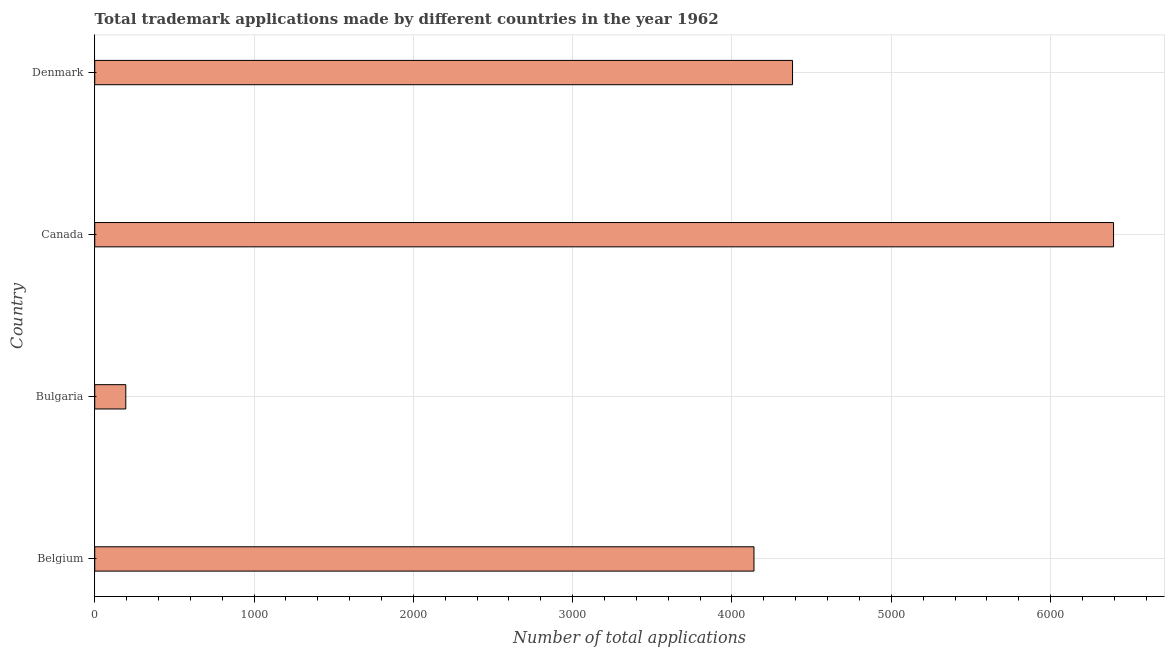What is the title of the graph?
Your response must be concise. Total trademark applications made by different countries in the year 1962. What is the label or title of the X-axis?
Your answer should be very brief. Number of total applications. What is the label or title of the Y-axis?
Offer a terse response. Country. What is the number of trademark applications in Denmark?
Give a very brief answer. 4380. Across all countries, what is the maximum number of trademark applications?
Provide a short and direct response. 6395. Across all countries, what is the minimum number of trademark applications?
Ensure brevity in your answer.  195. In which country was the number of trademark applications minimum?
Offer a terse response. Bulgaria. What is the sum of the number of trademark applications?
Offer a terse response. 1.51e+04. What is the difference between the number of trademark applications in Belgium and Denmark?
Your response must be concise. -242. What is the average number of trademark applications per country?
Offer a terse response. 3777. What is the median number of trademark applications?
Offer a terse response. 4259. What is the difference between the highest and the second highest number of trademark applications?
Offer a very short reply. 2015. What is the difference between the highest and the lowest number of trademark applications?
Provide a succinct answer. 6200. How many bars are there?
Ensure brevity in your answer.  4. How many countries are there in the graph?
Your response must be concise. 4. What is the difference between two consecutive major ticks on the X-axis?
Your answer should be compact. 1000. Are the values on the major ticks of X-axis written in scientific E-notation?
Ensure brevity in your answer.  No. What is the Number of total applications of Belgium?
Provide a succinct answer. 4138. What is the Number of total applications of Bulgaria?
Your answer should be very brief. 195. What is the Number of total applications in Canada?
Provide a succinct answer. 6395. What is the Number of total applications of Denmark?
Ensure brevity in your answer.  4380. What is the difference between the Number of total applications in Belgium and Bulgaria?
Provide a succinct answer. 3943. What is the difference between the Number of total applications in Belgium and Canada?
Make the answer very short. -2257. What is the difference between the Number of total applications in Belgium and Denmark?
Your response must be concise. -242. What is the difference between the Number of total applications in Bulgaria and Canada?
Provide a succinct answer. -6200. What is the difference between the Number of total applications in Bulgaria and Denmark?
Provide a short and direct response. -4185. What is the difference between the Number of total applications in Canada and Denmark?
Make the answer very short. 2015. What is the ratio of the Number of total applications in Belgium to that in Bulgaria?
Provide a short and direct response. 21.22. What is the ratio of the Number of total applications in Belgium to that in Canada?
Your answer should be very brief. 0.65. What is the ratio of the Number of total applications in Belgium to that in Denmark?
Offer a terse response. 0.94. What is the ratio of the Number of total applications in Bulgaria to that in Canada?
Keep it short and to the point. 0.03. What is the ratio of the Number of total applications in Bulgaria to that in Denmark?
Your response must be concise. 0.04. What is the ratio of the Number of total applications in Canada to that in Denmark?
Keep it short and to the point. 1.46. 